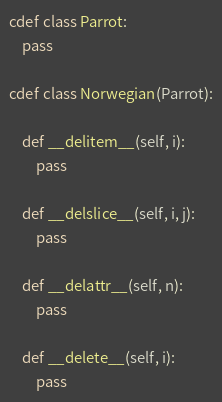<code> <loc_0><loc_0><loc_500><loc_500><_Cython_>cdef class Parrot:
	pass

cdef class Norwegian(Parrot):
	
	def __delitem__(self, i):
		pass
	
	def __delslice__(self, i, j):
		pass

	def __delattr__(self, n):
		pass

	def __delete__(self, i):
		pass
</code> 